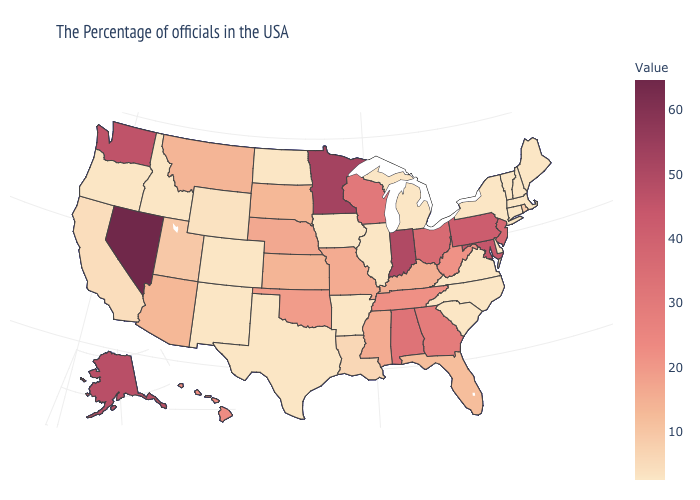Among the states that border Montana , does Idaho have the highest value?
Write a very short answer. No. Among the states that border Maryland , does Pennsylvania have the highest value?
Answer briefly. Yes. Among the states that border Illinois , which have the lowest value?
Short answer required. Iowa. 